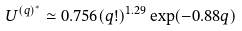<formula> <loc_0><loc_0><loc_500><loc_500>U ^ { ( q ) ^ { * } } \simeq 0 . 7 5 6 ( q ! ) ^ { 1 . 2 9 } \exp ( - 0 . 8 8 q )</formula> 